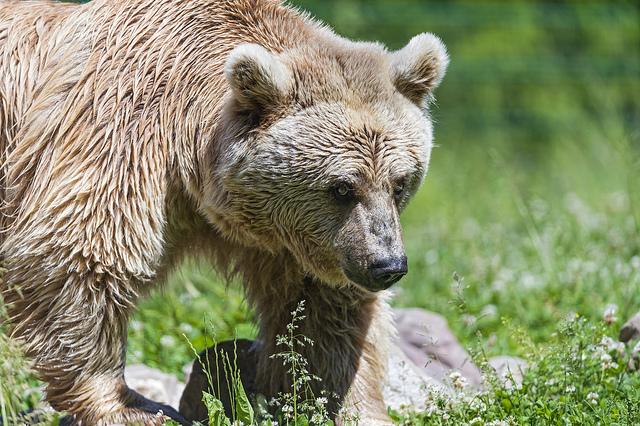Does the bear look hungry?
Concise answer only. Yes. Is this a black bear?
Answer briefly. No. What color is the bear?
Be succinct. Brown. 